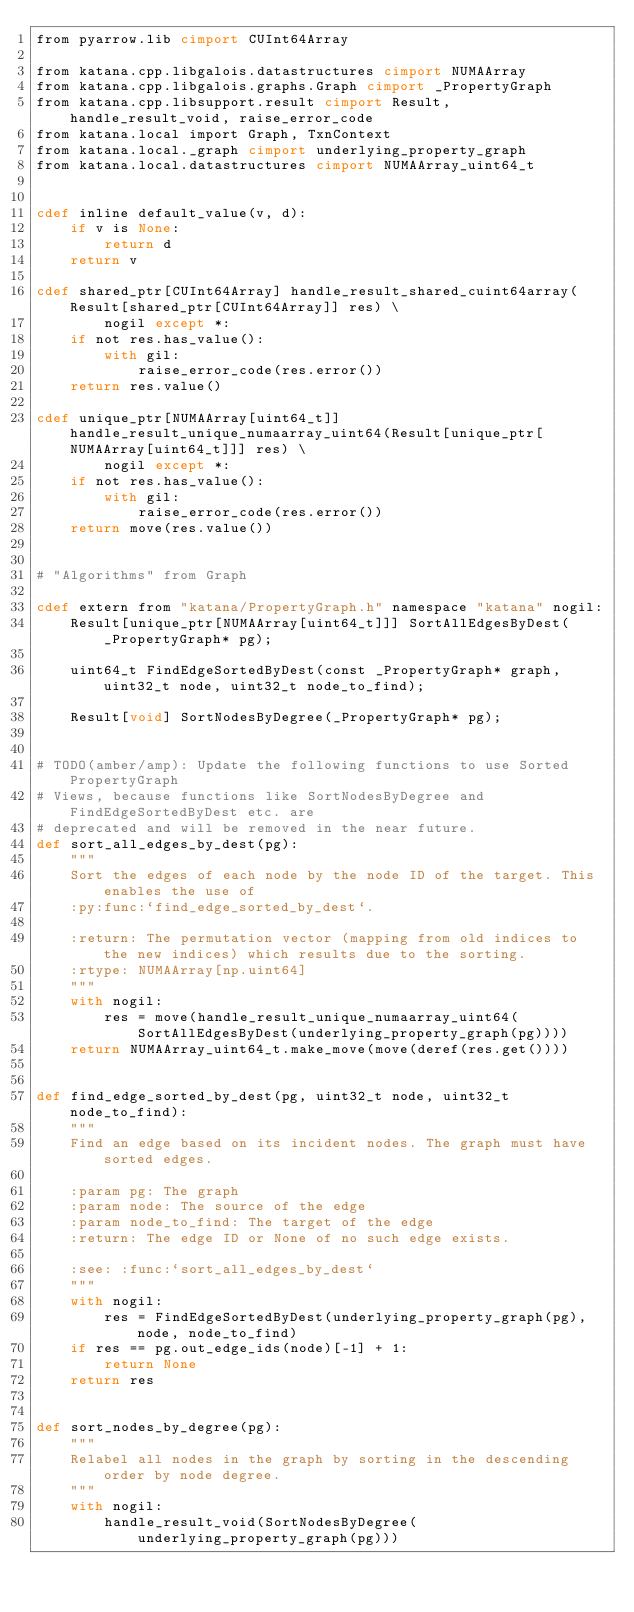Convert code to text. <code><loc_0><loc_0><loc_500><loc_500><_Cython_>from pyarrow.lib cimport CUInt64Array

from katana.cpp.libgalois.datastructures cimport NUMAArray
from katana.cpp.libgalois.graphs.Graph cimport _PropertyGraph
from katana.cpp.libsupport.result cimport Result, handle_result_void, raise_error_code
from katana.local import Graph, TxnContext
from katana.local._graph cimport underlying_property_graph
from katana.local.datastructures cimport NUMAArray_uint64_t


cdef inline default_value(v, d):
    if v is None:
        return d
    return v

cdef shared_ptr[CUInt64Array] handle_result_shared_cuint64array(Result[shared_ptr[CUInt64Array]] res) \
        nogil except *:
    if not res.has_value():
        with gil:
            raise_error_code(res.error())
    return res.value()

cdef unique_ptr[NUMAArray[uint64_t]] handle_result_unique_numaarray_uint64(Result[unique_ptr[NUMAArray[uint64_t]]] res) \
        nogil except *:
    if not res.has_value():
        with gil:
            raise_error_code(res.error())
    return move(res.value())


# "Algorithms" from Graph

cdef extern from "katana/PropertyGraph.h" namespace "katana" nogil:
    Result[unique_ptr[NUMAArray[uint64_t]]] SortAllEdgesByDest(_PropertyGraph* pg);

    uint64_t FindEdgeSortedByDest(const _PropertyGraph* graph, uint32_t node, uint32_t node_to_find);

    Result[void] SortNodesByDegree(_PropertyGraph* pg);


# TODO(amber/amp): Update the following functions to use Sorted PropertyGraph
# Views, because functions like SortNodesByDegree and FindEdgeSortedByDest etc. are
# deprecated and will be removed in the near future.
def sort_all_edges_by_dest(pg):
    """
    Sort the edges of each node by the node ID of the target. This enables the use of
    :py:func:`find_edge_sorted_by_dest`.

    :return: The permutation vector (mapping from old indices to the new indices) which results due to the sorting.
    :rtype: NUMAArray[np.uint64]
    """
    with nogil:
        res = move(handle_result_unique_numaarray_uint64(SortAllEdgesByDest(underlying_property_graph(pg))))
    return NUMAArray_uint64_t.make_move(move(deref(res.get())))


def find_edge_sorted_by_dest(pg, uint32_t node, uint32_t node_to_find):
    """
    Find an edge based on its incident nodes. The graph must have sorted edges.

    :param pg: The graph
    :param node: The source of the edge
    :param node_to_find: The target of the edge
    :return: The edge ID or None of no such edge exists.

    :see: :func:`sort_all_edges_by_dest`
    """
    with nogil:
        res = FindEdgeSortedByDest(underlying_property_graph(pg), node, node_to_find)
    if res == pg.out_edge_ids(node)[-1] + 1:
        return None
    return res


def sort_nodes_by_degree(pg):
    """
    Relabel all nodes in the graph by sorting in the descending order by node degree.
    """
    with nogil:
        handle_result_void(SortNodesByDegree(underlying_property_graph(pg)))
</code> 